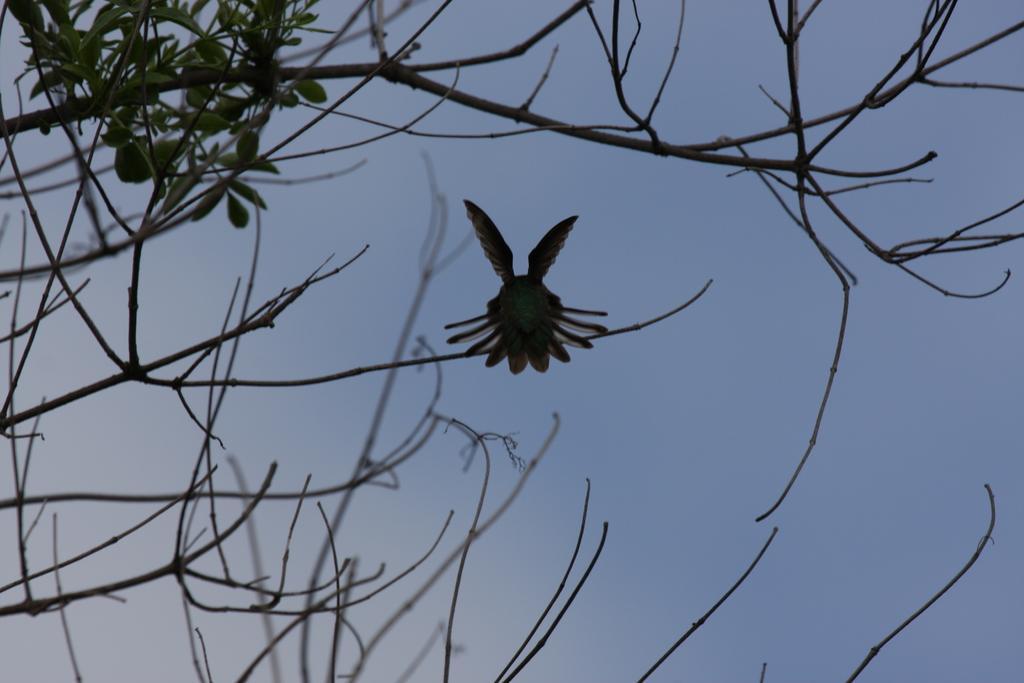Please provide a concise description of this image. In this image I can see a bird on the branch. I can also see a tree, and sky is in blue color. 